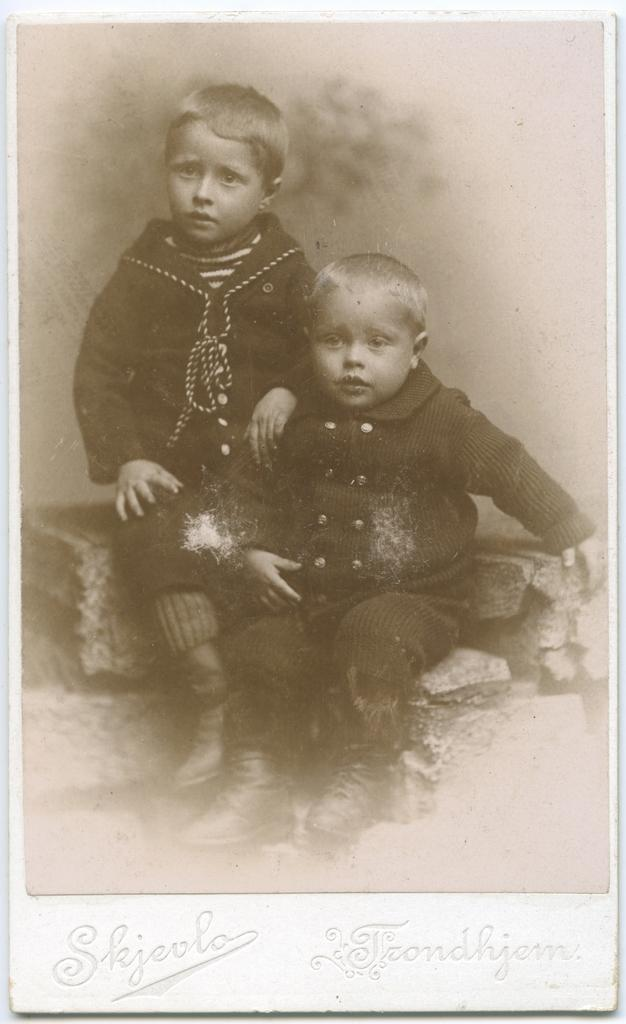What is the color scheme of the image? The image is in black and white. How many people are in the image? There are two boys in the image. What are the boys doing in the image? The boys are sitting. What type of engine can be seen in the image? There is no engine present in the image; it features two boys sitting. What type of blade is being used by the boys in the image? There is no blade present in the image; the boys are simply sitting. 